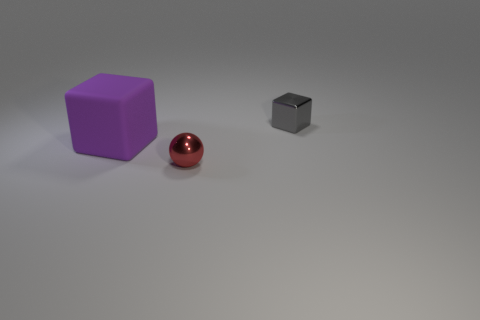Add 3 large matte objects. How many objects exist? 6 Subtract all spheres. How many objects are left? 2 Add 1 large purple blocks. How many large purple blocks exist? 2 Subtract 0 blue spheres. How many objects are left? 3 Subtract all tiny blue rubber objects. Subtract all small gray cubes. How many objects are left? 2 Add 3 purple rubber things. How many purple rubber things are left? 4 